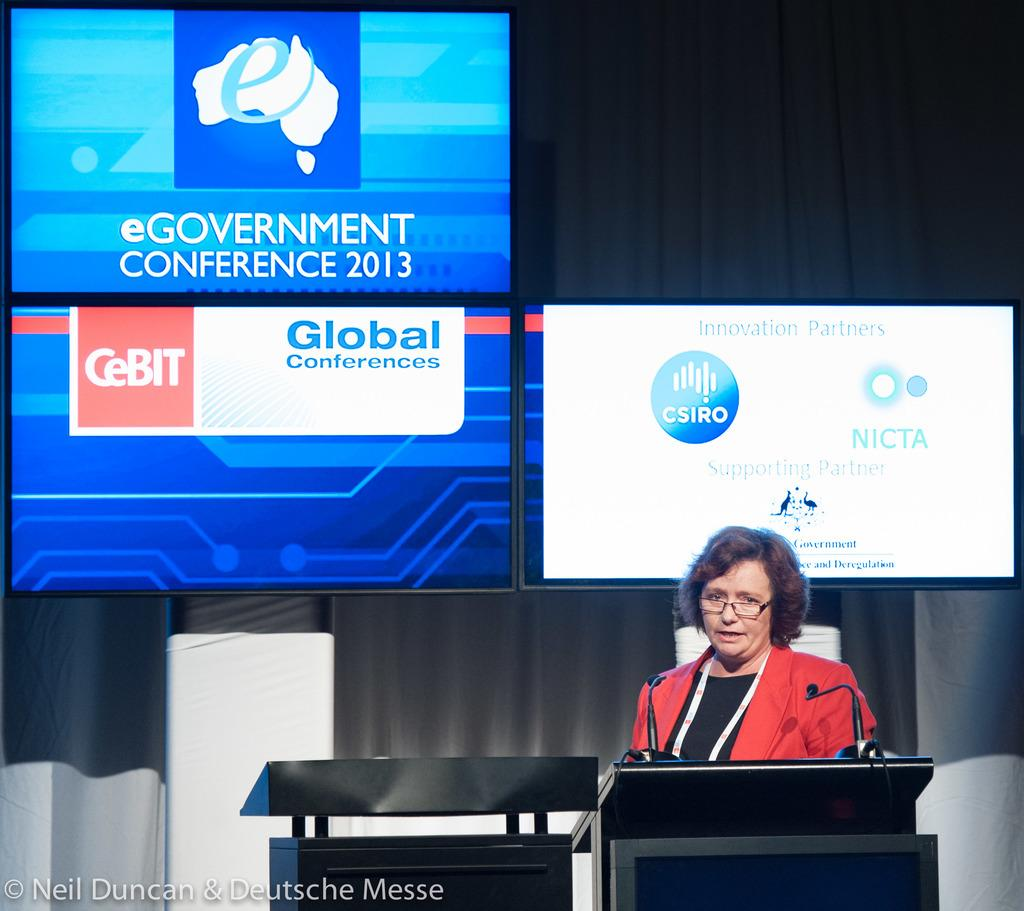<image>
Present a compact description of the photo's key features. A woman stands at a podium with displays behind her for the eGovernment Conference in 2013. 